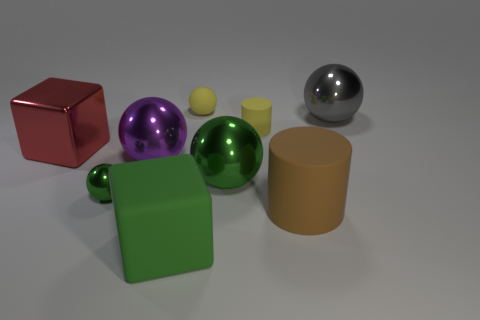Do the matte sphere and the large matte thing that is to the right of the big matte block have the same color?
Make the answer very short. No. Are there any large purple spheres right of the large green cube?
Your answer should be very brief. No. There is a shiny sphere that is on the right side of the yellow matte cylinder; is its size the same as the sphere to the left of the purple object?
Provide a succinct answer. No. Are there any cyan balls that have the same size as the green matte block?
Keep it short and to the point. No. Do the green shiny object right of the green cube and the big red thing have the same shape?
Your answer should be very brief. No. There is a object that is on the right side of the big brown object; what is it made of?
Offer a terse response. Metal. What shape is the large green matte thing that is in front of the ball right of the yellow cylinder?
Give a very brief answer. Cube. Does the large purple thing have the same shape as the large green object to the right of the large rubber block?
Keep it short and to the point. Yes. There is a cylinder that is to the right of the yellow cylinder; how many big spheres are left of it?
Provide a short and direct response. 2. What is the material of the yellow thing that is the same shape as the gray thing?
Provide a succinct answer. Rubber. 